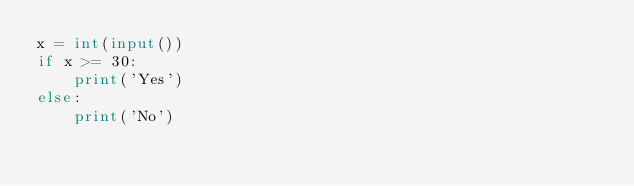Convert code to text. <code><loc_0><loc_0><loc_500><loc_500><_Python_>x = int(input())
if x >= 30:
    print('Yes')
else:
    print('No')</code> 